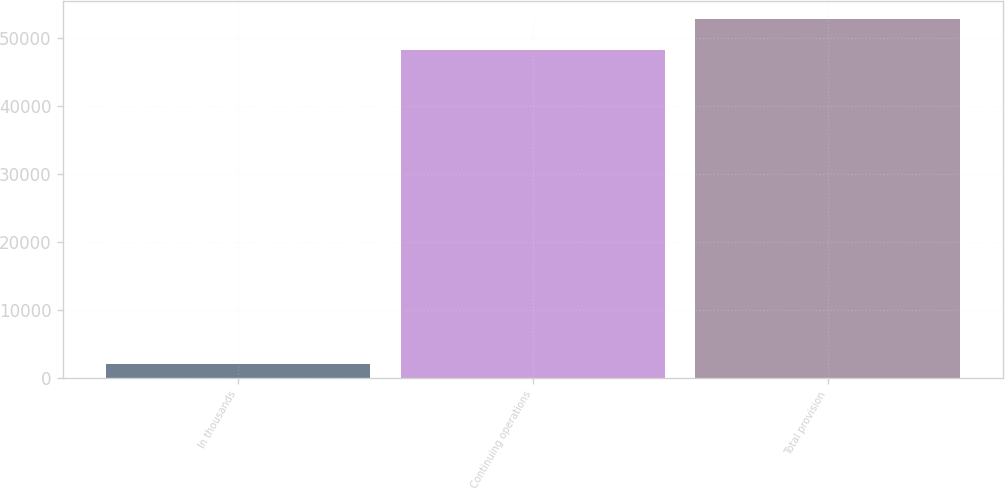Convert chart. <chart><loc_0><loc_0><loc_500><loc_500><bar_chart><fcel>In thousands<fcel>Continuing operations<fcel>Total provision<nl><fcel>2009<fcel>48304<fcel>52933.5<nl></chart> 